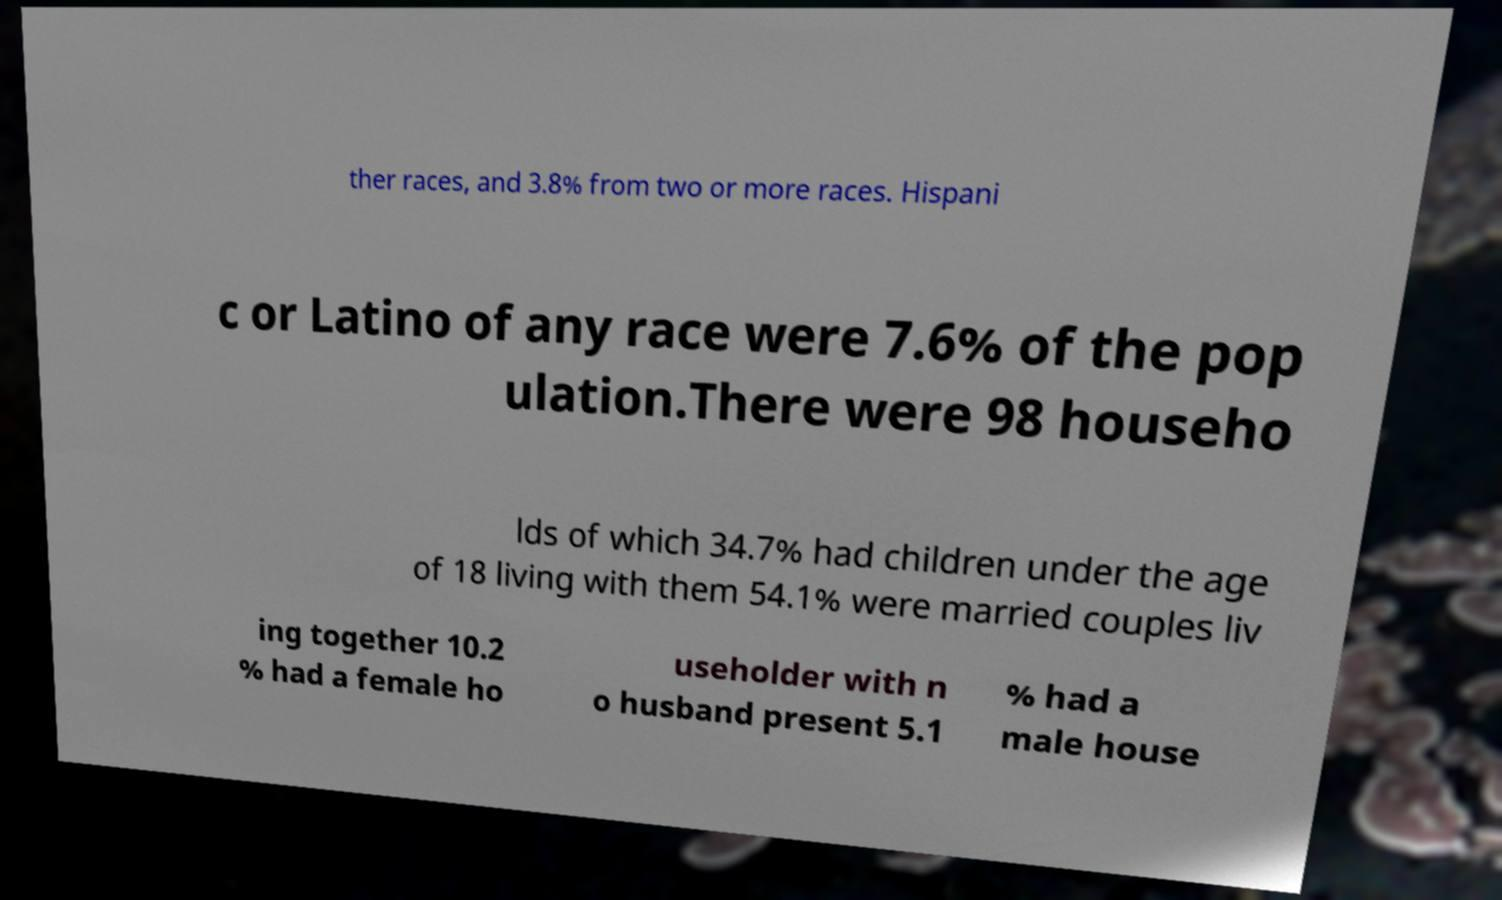For documentation purposes, I need the text within this image transcribed. Could you provide that? ther races, and 3.8% from two or more races. Hispani c or Latino of any race were 7.6% of the pop ulation.There were 98 househo lds of which 34.7% had children under the age of 18 living with them 54.1% were married couples liv ing together 10.2 % had a female ho useholder with n o husband present 5.1 % had a male house 